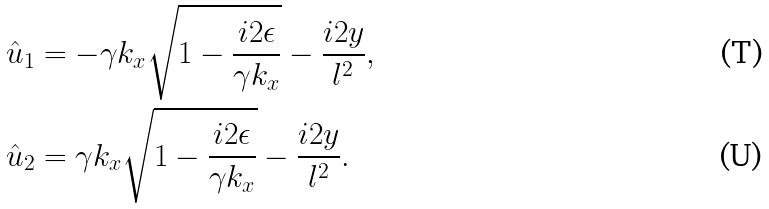Convert formula to latex. <formula><loc_0><loc_0><loc_500><loc_500>\hat { u } _ { 1 } & = - \gamma k _ { x } \sqrt { 1 - \frac { i 2 \epsilon } { \gamma k _ { x } } } - \frac { i 2 y } { l ^ { 2 } } , \\ \hat { u } _ { 2 } & = \gamma k _ { x } \sqrt { 1 - \frac { i 2 \epsilon } { \gamma k _ { x } } } - \frac { i 2 y } { l ^ { 2 } } .</formula> 